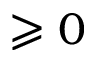Convert formula to latex. <formula><loc_0><loc_0><loc_500><loc_500>\geqslant 0</formula> 